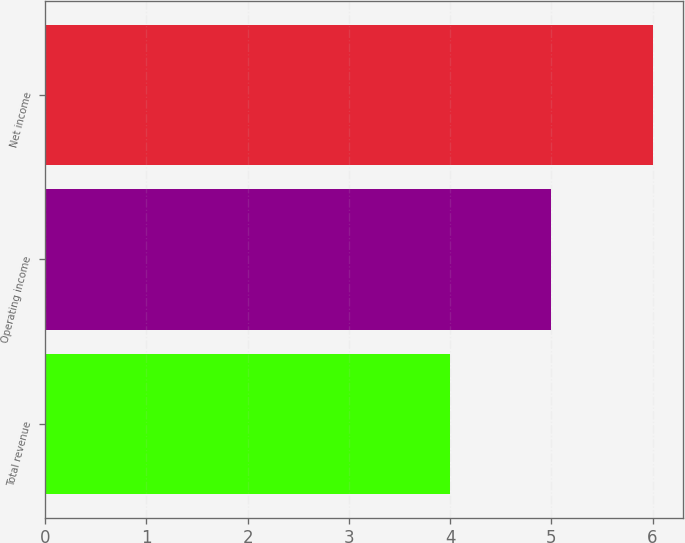Convert chart. <chart><loc_0><loc_0><loc_500><loc_500><bar_chart><fcel>Total revenue<fcel>Operating income<fcel>Net income<nl><fcel>4<fcel>5<fcel>6<nl></chart> 